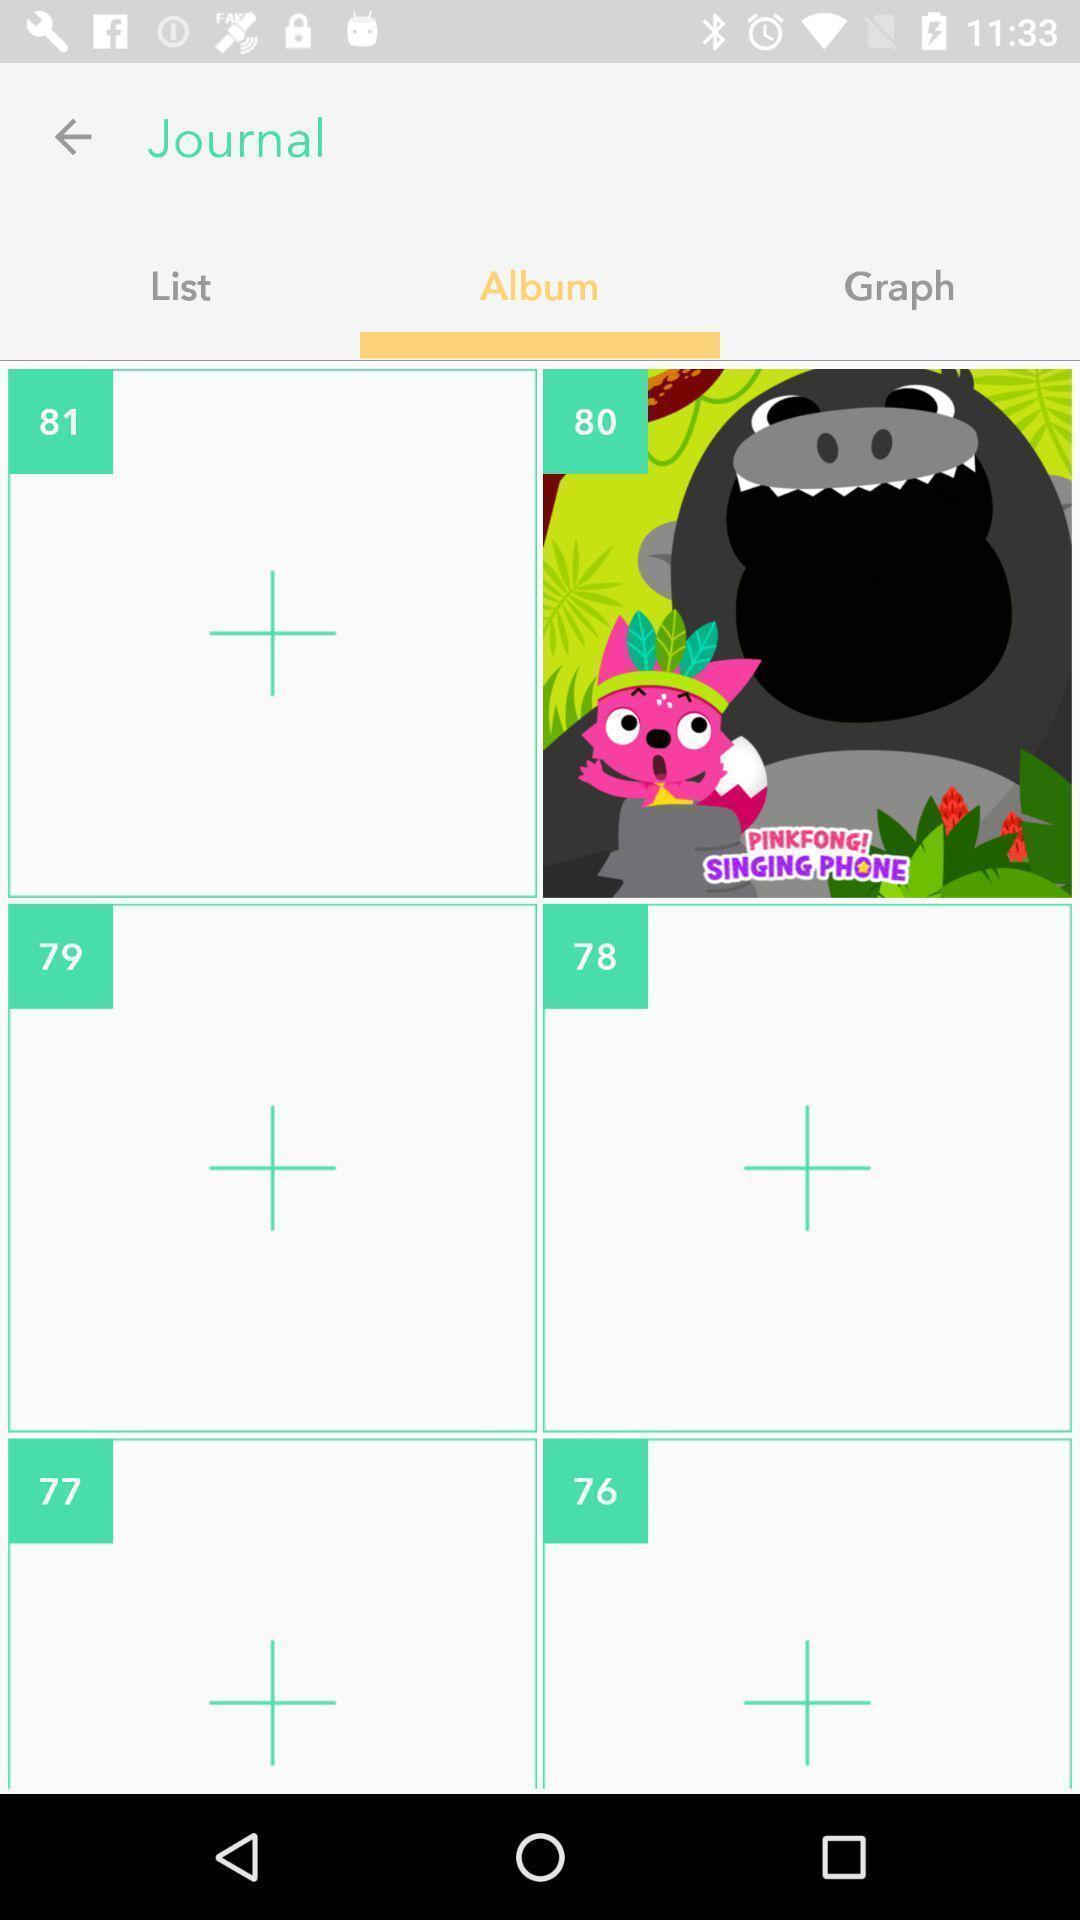Explain the elements present in this screenshot. Screen shows album details. 